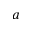Convert formula to latex. <formula><loc_0><loc_0><loc_500><loc_500>a</formula> 